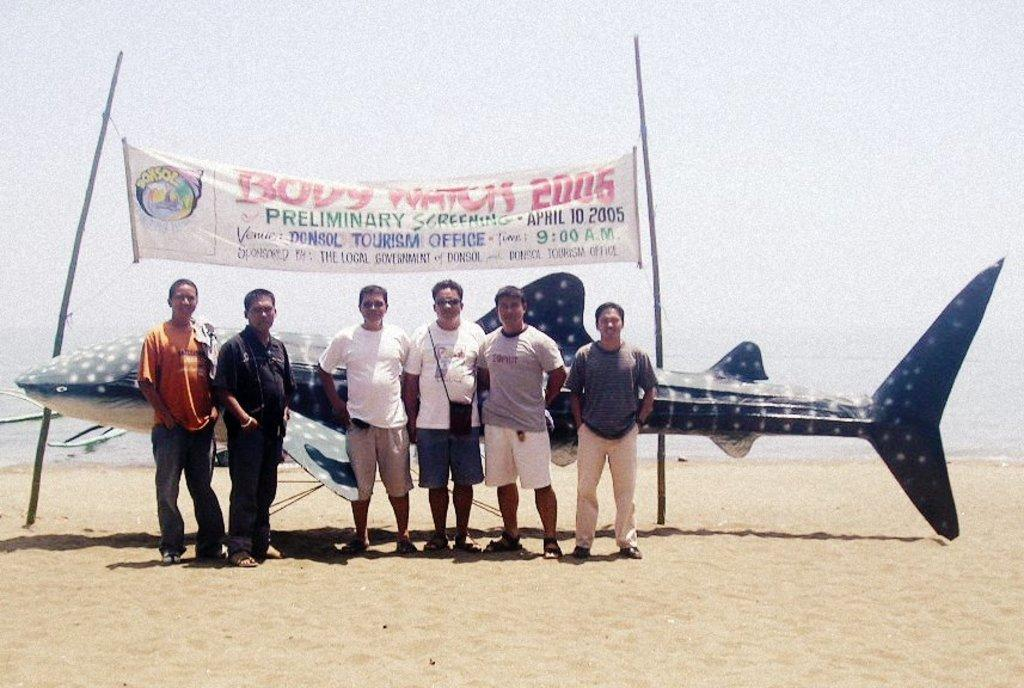Provide a one-sentence caption for the provided image. People stand in front of a display made by the tourism office. 